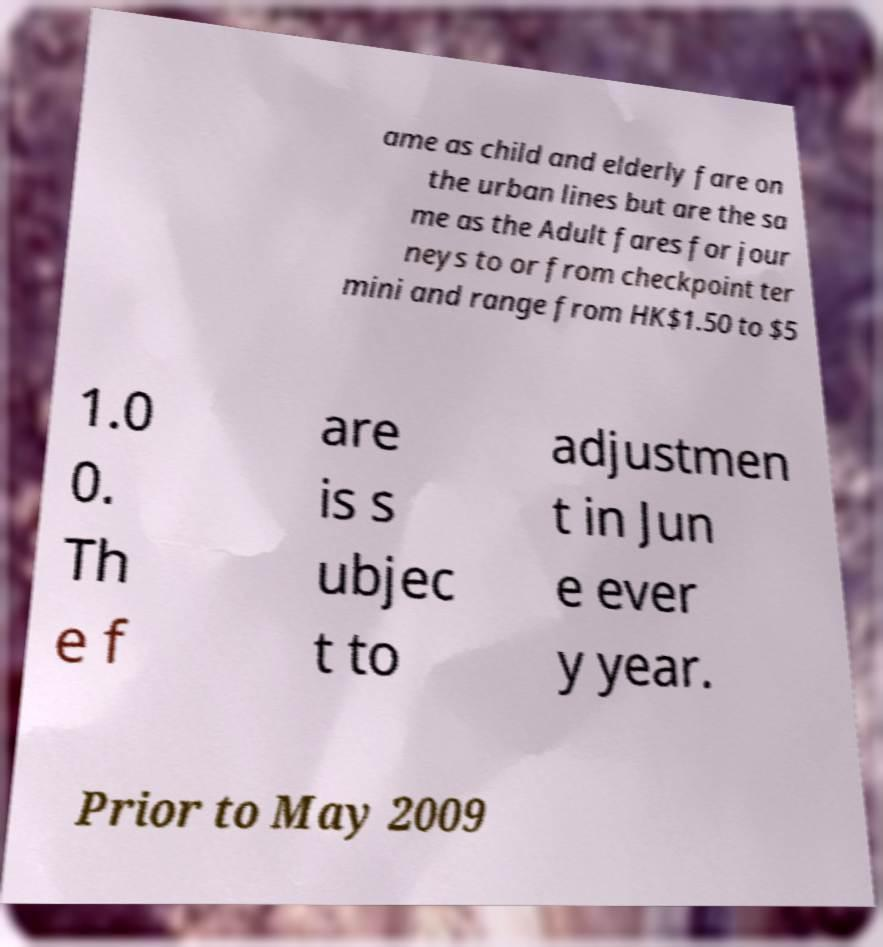For documentation purposes, I need the text within this image transcribed. Could you provide that? ame as child and elderly fare on the urban lines but are the sa me as the Adult fares for jour neys to or from checkpoint ter mini and range from HK$1.50 to $5 1.0 0. Th e f are is s ubjec t to adjustmen t in Jun e ever y year. Prior to May 2009 